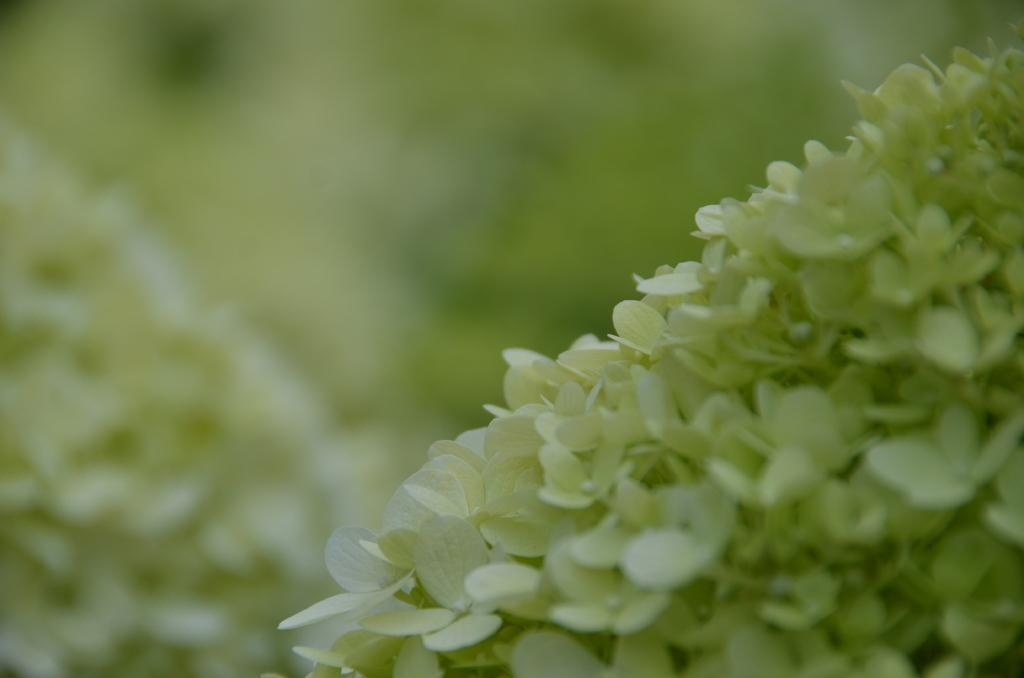How would you summarize this image in a sentence or two? As we can see in the image in the front there are white color flowers and the background is blurred. 